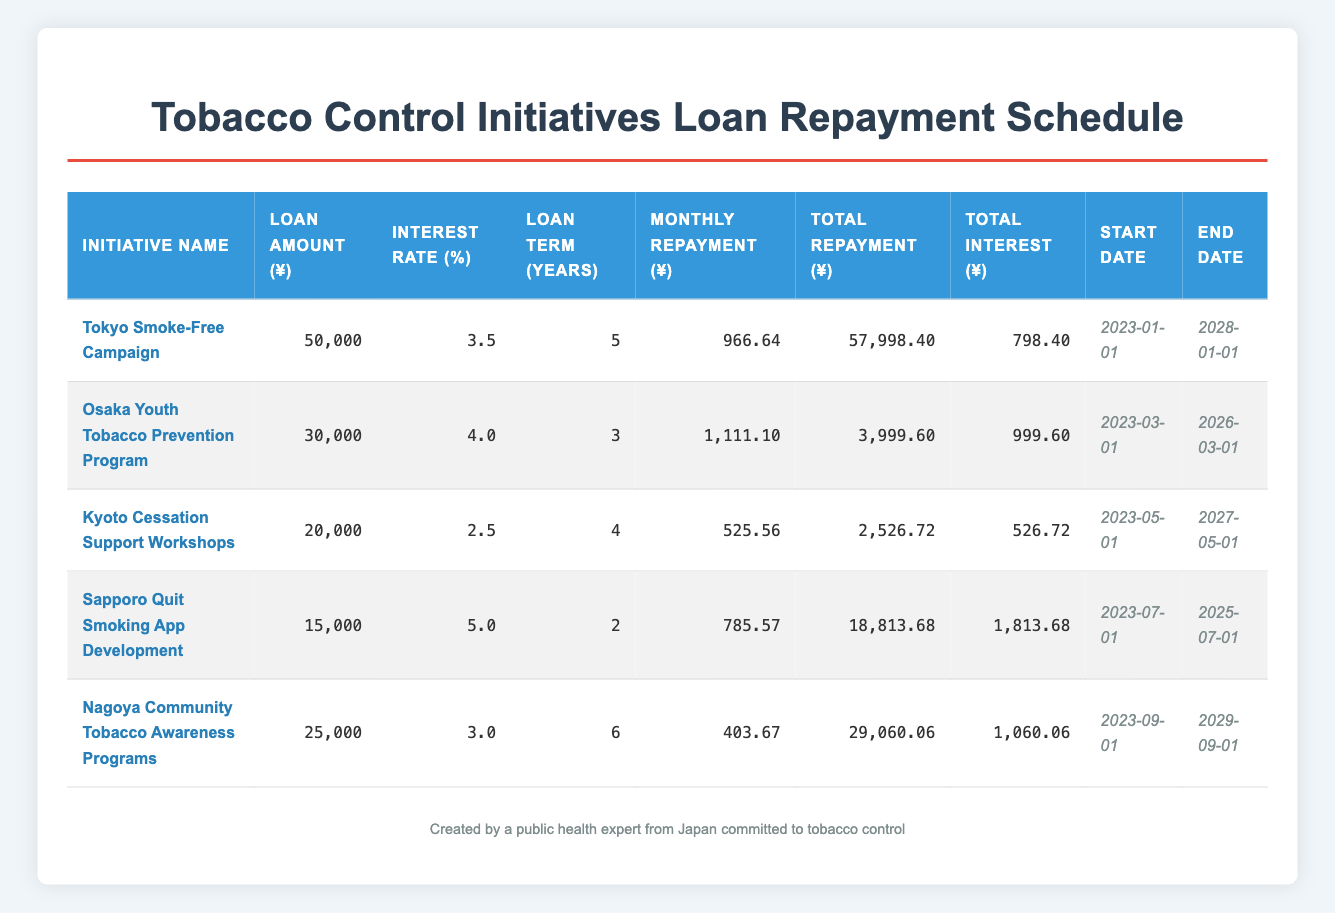What is the total loan amount for all initiatives combined? To find the total loan amount, I will add the loan amounts of each initiative: 50000 + 30000 + 20000 + 15000 + 25000 = 140000.
Answer: 140000 What is the monthly repayment for the Kyoto Cessation Support Workshops? The monthly repayment for this initiative is directly found in the table, which shows 525.56.
Answer: 525.56 Is the total interest for the Sapporo Quit Smoking App Development greater than 1500? The total interest for Sapporo Quit Smoking App Development is 1813.68, which is indeed greater than 1500.
Answer: Yes What is the average interest rate across all initiatives? To find the average interest rate, I will sum the interest rates: 3.5 + 4.0 + 2.5 + 5.0 + 3.0 = 18.0. Then I divide by the number of initiatives (5): 18.0 / 5 = 3.6.
Answer: 3.6 Which initiative has the longest loan term and what is its duration? Looking at the loan term column, the Nagoya Community Tobacco Awareness Programs have a loan term of 6 years, which is the longest.
Answer: Nagoya Community Tobacco Awareness Programs, 6 years What is the total repayment amount for the Osaka Youth Tobacco Prevention Program? The total repayment amount can be directly read from the table for this initiative, which is 3999.60.
Answer: 3999.60 How much more is the monthly repayment for the Tokyo Smoke-Free Campaign compared to the Kyoto Cessation Support Workshops? The monthly repayment for Tokyo is 966.64, and for Kyoto is 525.56. The difference is 966.64 - 525.56 = 441.08.
Answer: 441.08 Is the total repayment for the Nagoya Community Tobacco Awareness Programs less than 30000? The total repayment for this initiative is 29060.06, which is indeed less than 30000.
Answer: Yes What is the range of total interest amounts across all initiatives? The total interest amounts are 798.40, 999.60, 526.72, 1813.68, and 1060.06. The range is calculated by finding the difference between the maximum (1813.68) and minimum (526.72) values: 1813.68 - 526.72 = 1286.96.
Answer: 1286.96 